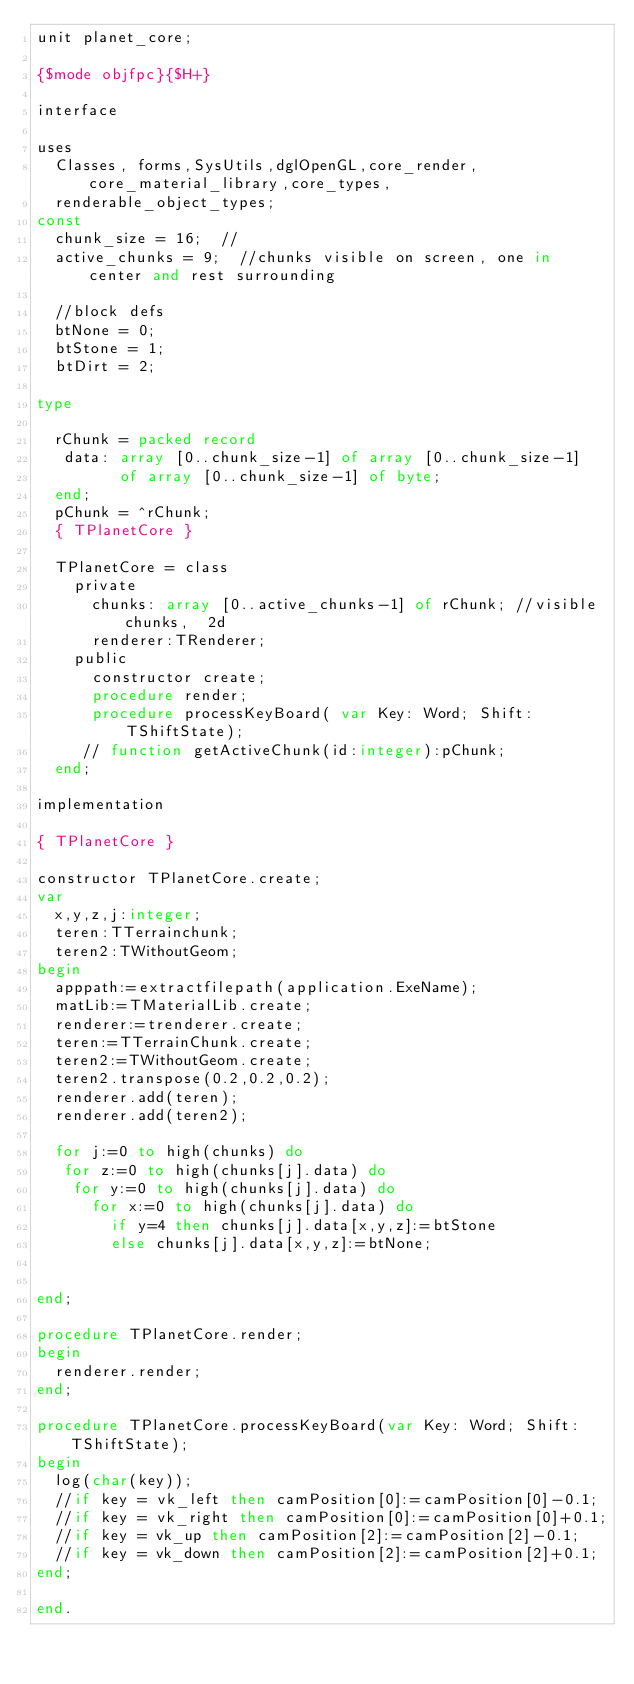<code> <loc_0><loc_0><loc_500><loc_500><_Pascal_>unit planet_core;

{$mode objfpc}{$H+}

interface

uses
  Classes, forms,SysUtils,dglOpenGL,core_render,core_material_library,core_types,
  renderable_object_types;
const
  chunk_size = 16;  //
  active_chunks = 9;  //chunks visible on screen, one in center and rest surrounding

  //block defs
  btNone = 0;
  btStone = 1;
  btDirt = 2;

type

  rChunk = packed record
   data: array [0..chunk_size-1] of array [0..chunk_size-1]
         of array [0..chunk_size-1] of byte;
  end;
  pChunk = ^rChunk;
  { TPlanetCore }

  TPlanetCore = class
    private
      chunks: array [0..active_chunks-1] of rChunk; //visible chunks,  2d
      renderer:TRenderer;
    public
      constructor create;
      procedure render;
      procedure processKeyBoard( var Key: Word; Shift: TShiftState);
     // function getActiveChunk(id:integer):pChunk;
  end;

implementation

{ TPlanetCore }

constructor TPlanetCore.create;
var
  x,y,z,j:integer;
  teren:TTerrainchunk;
  teren2:TWithoutGeom;
begin
  apppath:=extractfilepath(application.ExeName);
  matLib:=TMaterialLib.create;
  renderer:=trenderer.create;
  teren:=TTerrainChunk.create;
  teren2:=TWithoutGeom.create;
  teren2.transpose(0.2,0.2,0.2);
  renderer.add(teren);
  renderer.add(teren2);

  for j:=0 to high(chunks) do
   for z:=0 to high(chunks[j].data) do
    for y:=0 to high(chunks[j].data) do
      for x:=0 to high(chunks[j].data) do
        if y=4 then chunks[j].data[x,y,z]:=btStone
        else chunks[j].data[x,y,z]:=btNone;


end;

procedure TPlanetCore.render;
begin
  renderer.render;
end;

procedure TPlanetCore.processKeyBoard(var Key: Word; Shift: TShiftState);
begin
  log(char(key));
  //if key = vk_left then camPosition[0]:=camPosition[0]-0.1;
  //if key = vk_right then camPosition[0]:=camPosition[0]+0.1;
  //if key = vk_up then camPosition[2]:=camPosition[2]-0.1;
  //if key = vk_down then camPosition[2]:=camPosition[2]+0.1;
end;

end.

</code> 